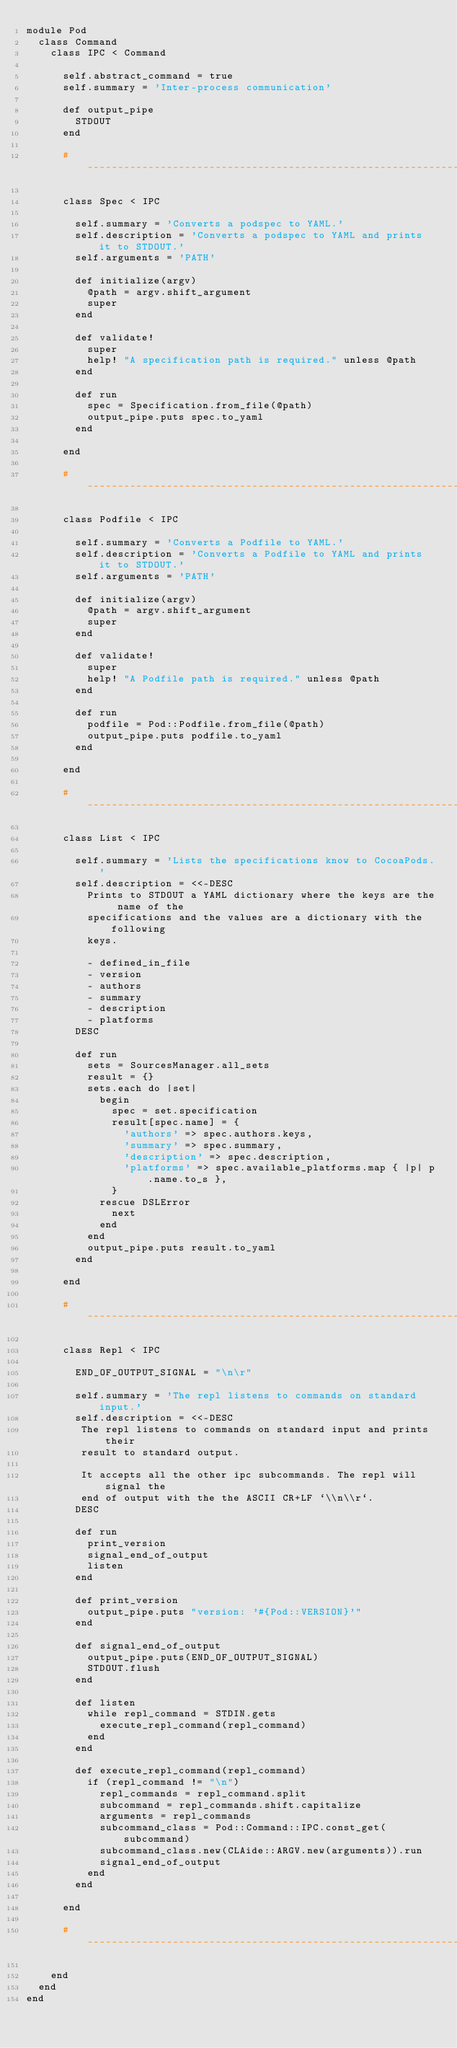Convert code to text. <code><loc_0><loc_0><loc_500><loc_500><_Ruby_>module Pod
  class Command
    class IPC < Command

      self.abstract_command = true
      self.summary = 'Inter-process communication'

      def output_pipe
        STDOUT
      end

      #-----------------------------------------------------------------------#

      class Spec < IPC

        self.summary = 'Converts a podspec to YAML.'
        self.description = 'Converts a podspec to YAML and prints it to STDOUT.'
        self.arguments = 'PATH'

        def initialize(argv)
          @path = argv.shift_argument
          super
        end

        def validate!
          super
          help! "A specification path is required." unless @path
        end

        def run
          spec = Specification.from_file(@path)
          output_pipe.puts spec.to_yaml
        end

      end

      #-----------------------------------------------------------------------#

      class Podfile < IPC

        self.summary = 'Converts a Podfile to YAML.'
        self.description = 'Converts a Podfile to YAML and prints it to STDOUT.'
        self.arguments = 'PATH'

        def initialize(argv)
          @path = argv.shift_argument
          super
        end

        def validate!
          super
          help! "A Podfile path is required." unless @path
        end

        def run
          podfile = Pod::Podfile.from_file(@path)
          output_pipe.puts podfile.to_yaml
        end

      end

      #-----------------------------------------------------------------------#

      class List < IPC

        self.summary = 'Lists the specifications know to CocoaPods.'
        self.description = <<-DESC
          Prints to STDOUT a YAML dictionary where the keys are the name of the
          specifications and the values are a dictionary with the following
          keys.

          - defined_in_file
          - version
          - authors
          - summary
          - description
          - platforms
        DESC

        def run
          sets = SourcesManager.all_sets
          result = {}
          sets.each do |set|
            begin
              spec = set.specification
              result[spec.name] = {
                'authors' => spec.authors.keys,
                'summary' => spec.summary,
                'description' => spec.description,
                'platforms' => spec.available_platforms.map { |p| p.name.to_s },
              }
            rescue DSLError
              next
            end
          end
          output_pipe.puts result.to_yaml
        end

      end

      #-----------------------------------------------------------------------#

      class Repl < IPC

        END_OF_OUTPUT_SIGNAL = "\n\r"

        self.summary = 'The repl listens to commands on standard input.'
        self.description = <<-DESC
         The repl listens to commands on standard input and prints their
         result to standard output.

         It accepts all the other ipc subcommands. The repl will signal the
         end of output with the the ASCII CR+LF `\\n\\r`.
        DESC

        def run
          print_version
          signal_end_of_output
          listen
        end

        def print_version
          output_pipe.puts "version: '#{Pod::VERSION}'"
        end

        def signal_end_of_output
          output_pipe.puts(END_OF_OUTPUT_SIGNAL)
          STDOUT.flush
        end

        def listen
          while repl_command = STDIN.gets
            execute_repl_command(repl_command)
          end
        end

        def execute_repl_command(repl_command)
          if (repl_command != "\n")
            repl_commands = repl_command.split
            subcommand = repl_commands.shift.capitalize
            arguments = repl_commands
            subcommand_class = Pod::Command::IPC.const_get(subcommand)
            subcommand_class.new(CLAide::ARGV.new(arguments)).run
            signal_end_of_output
          end
        end

      end

      #-----------------------------------------------------------------------#

    end
  end
end
</code> 